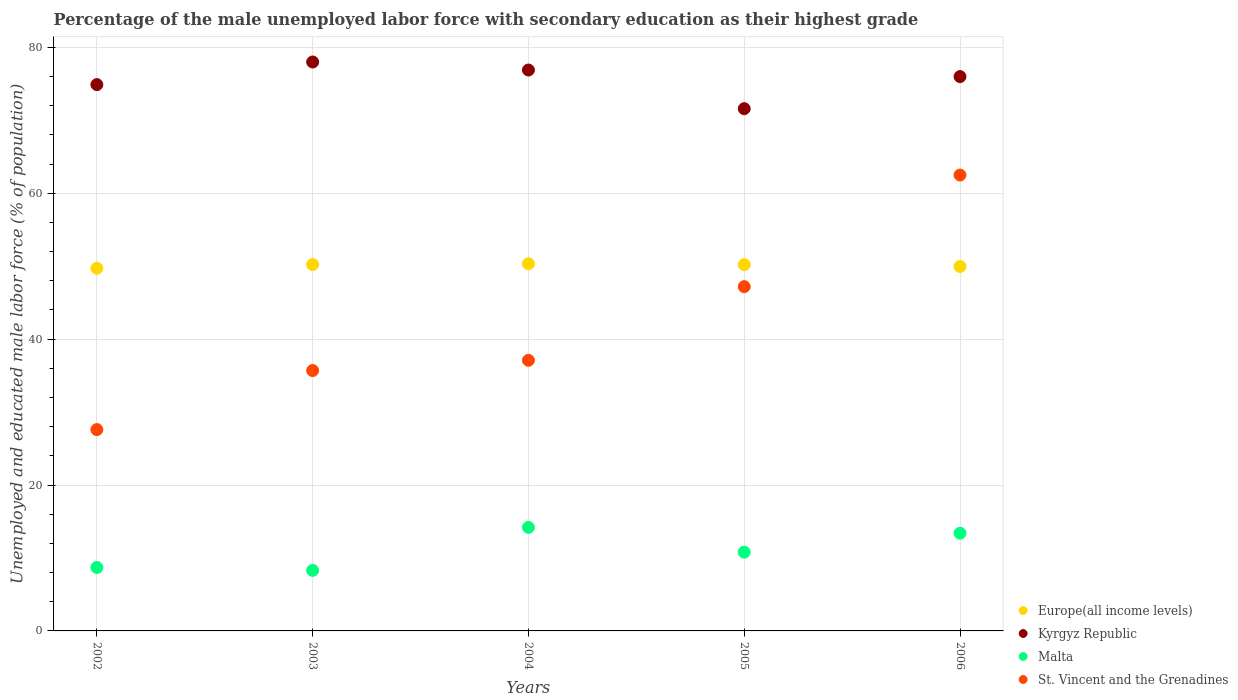What is the percentage of the unemployed male labor force with secondary education in Malta in 2003?
Make the answer very short. 8.3. Across all years, what is the minimum percentage of the unemployed male labor force with secondary education in Kyrgyz Republic?
Give a very brief answer. 71.6. In which year was the percentage of the unemployed male labor force with secondary education in St. Vincent and the Grenadines maximum?
Your response must be concise. 2006. What is the total percentage of the unemployed male labor force with secondary education in Malta in the graph?
Offer a very short reply. 55.4. What is the difference between the percentage of the unemployed male labor force with secondary education in Europe(all income levels) in 2002 and that in 2004?
Offer a terse response. -0.61. What is the difference between the percentage of the unemployed male labor force with secondary education in Malta in 2002 and the percentage of the unemployed male labor force with secondary education in St. Vincent and the Grenadines in 2005?
Offer a terse response. -38.5. What is the average percentage of the unemployed male labor force with secondary education in Malta per year?
Make the answer very short. 11.08. In the year 2004, what is the difference between the percentage of the unemployed male labor force with secondary education in Kyrgyz Republic and percentage of the unemployed male labor force with secondary education in Europe(all income levels)?
Provide a succinct answer. 26.56. In how many years, is the percentage of the unemployed male labor force with secondary education in Europe(all income levels) greater than 20 %?
Your answer should be very brief. 5. What is the ratio of the percentage of the unemployed male labor force with secondary education in Europe(all income levels) in 2003 to that in 2004?
Your answer should be compact. 1. What is the difference between the highest and the second highest percentage of the unemployed male labor force with secondary education in Malta?
Your response must be concise. 0.8. What is the difference between the highest and the lowest percentage of the unemployed male labor force with secondary education in Kyrgyz Republic?
Give a very brief answer. 6.4. Is the sum of the percentage of the unemployed male labor force with secondary education in Kyrgyz Republic in 2004 and 2006 greater than the maximum percentage of the unemployed male labor force with secondary education in Malta across all years?
Offer a terse response. Yes. Is it the case that in every year, the sum of the percentage of the unemployed male labor force with secondary education in Europe(all income levels) and percentage of the unemployed male labor force with secondary education in Malta  is greater than the percentage of the unemployed male labor force with secondary education in St. Vincent and the Grenadines?
Your response must be concise. Yes. Is the percentage of the unemployed male labor force with secondary education in Malta strictly greater than the percentage of the unemployed male labor force with secondary education in St. Vincent and the Grenadines over the years?
Provide a short and direct response. No. How many dotlines are there?
Provide a succinct answer. 4. How many years are there in the graph?
Provide a short and direct response. 5. What is the difference between two consecutive major ticks on the Y-axis?
Keep it short and to the point. 20. Does the graph contain any zero values?
Your answer should be compact. No. Where does the legend appear in the graph?
Provide a short and direct response. Bottom right. What is the title of the graph?
Your answer should be compact. Percentage of the male unemployed labor force with secondary education as their highest grade. Does "Liechtenstein" appear as one of the legend labels in the graph?
Your answer should be compact. No. What is the label or title of the X-axis?
Give a very brief answer. Years. What is the label or title of the Y-axis?
Offer a very short reply. Unemployed and educated male labor force (% of population). What is the Unemployed and educated male labor force (% of population) in Europe(all income levels) in 2002?
Ensure brevity in your answer.  49.72. What is the Unemployed and educated male labor force (% of population) in Kyrgyz Republic in 2002?
Give a very brief answer. 74.9. What is the Unemployed and educated male labor force (% of population) in Malta in 2002?
Give a very brief answer. 8.7. What is the Unemployed and educated male labor force (% of population) in St. Vincent and the Grenadines in 2002?
Give a very brief answer. 27.6. What is the Unemployed and educated male labor force (% of population) in Europe(all income levels) in 2003?
Offer a very short reply. 50.23. What is the Unemployed and educated male labor force (% of population) of Kyrgyz Republic in 2003?
Your answer should be very brief. 78. What is the Unemployed and educated male labor force (% of population) of Malta in 2003?
Provide a succinct answer. 8.3. What is the Unemployed and educated male labor force (% of population) of St. Vincent and the Grenadines in 2003?
Your answer should be compact. 35.7. What is the Unemployed and educated male labor force (% of population) in Europe(all income levels) in 2004?
Provide a succinct answer. 50.34. What is the Unemployed and educated male labor force (% of population) of Kyrgyz Republic in 2004?
Provide a succinct answer. 76.9. What is the Unemployed and educated male labor force (% of population) in Malta in 2004?
Offer a very short reply. 14.2. What is the Unemployed and educated male labor force (% of population) in St. Vincent and the Grenadines in 2004?
Make the answer very short. 37.1. What is the Unemployed and educated male labor force (% of population) in Europe(all income levels) in 2005?
Give a very brief answer. 50.22. What is the Unemployed and educated male labor force (% of population) of Kyrgyz Republic in 2005?
Make the answer very short. 71.6. What is the Unemployed and educated male labor force (% of population) in Malta in 2005?
Your answer should be compact. 10.8. What is the Unemployed and educated male labor force (% of population) of St. Vincent and the Grenadines in 2005?
Your response must be concise. 47.2. What is the Unemployed and educated male labor force (% of population) of Europe(all income levels) in 2006?
Your response must be concise. 49.97. What is the Unemployed and educated male labor force (% of population) of Malta in 2006?
Your answer should be very brief. 13.4. What is the Unemployed and educated male labor force (% of population) of St. Vincent and the Grenadines in 2006?
Your response must be concise. 62.5. Across all years, what is the maximum Unemployed and educated male labor force (% of population) in Europe(all income levels)?
Your answer should be compact. 50.34. Across all years, what is the maximum Unemployed and educated male labor force (% of population) in Malta?
Give a very brief answer. 14.2. Across all years, what is the maximum Unemployed and educated male labor force (% of population) of St. Vincent and the Grenadines?
Your response must be concise. 62.5. Across all years, what is the minimum Unemployed and educated male labor force (% of population) in Europe(all income levels)?
Make the answer very short. 49.72. Across all years, what is the minimum Unemployed and educated male labor force (% of population) in Kyrgyz Republic?
Your response must be concise. 71.6. Across all years, what is the minimum Unemployed and educated male labor force (% of population) of Malta?
Offer a very short reply. 8.3. Across all years, what is the minimum Unemployed and educated male labor force (% of population) in St. Vincent and the Grenadines?
Keep it short and to the point. 27.6. What is the total Unemployed and educated male labor force (% of population) of Europe(all income levels) in the graph?
Your response must be concise. 250.47. What is the total Unemployed and educated male labor force (% of population) in Kyrgyz Republic in the graph?
Offer a terse response. 377.4. What is the total Unemployed and educated male labor force (% of population) of Malta in the graph?
Offer a terse response. 55.4. What is the total Unemployed and educated male labor force (% of population) of St. Vincent and the Grenadines in the graph?
Offer a terse response. 210.1. What is the difference between the Unemployed and educated male labor force (% of population) of Europe(all income levels) in 2002 and that in 2003?
Give a very brief answer. -0.51. What is the difference between the Unemployed and educated male labor force (% of population) of Malta in 2002 and that in 2003?
Give a very brief answer. 0.4. What is the difference between the Unemployed and educated male labor force (% of population) in Europe(all income levels) in 2002 and that in 2004?
Your response must be concise. -0.61. What is the difference between the Unemployed and educated male labor force (% of population) of Malta in 2002 and that in 2004?
Make the answer very short. -5.5. What is the difference between the Unemployed and educated male labor force (% of population) of St. Vincent and the Grenadines in 2002 and that in 2004?
Provide a short and direct response. -9.5. What is the difference between the Unemployed and educated male labor force (% of population) of Europe(all income levels) in 2002 and that in 2005?
Make the answer very short. -0.49. What is the difference between the Unemployed and educated male labor force (% of population) in St. Vincent and the Grenadines in 2002 and that in 2005?
Provide a succinct answer. -19.6. What is the difference between the Unemployed and educated male labor force (% of population) in Europe(all income levels) in 2002 and that in 2006?
Provide a short and direct response. -0.24. What is the difference between the Unemployed and educated male labor force (% of population) in Malta in 2002 and that in 2006?
Offer a terse response. -4.7. What is the difference between the Unemployed and educated male labor force (% of population) of St. Vincent and the Grenadines in 2002 and that in 2006?
Make the answer very short. -34.9. What is the difference between the Unemployed and educated male labor force (% of population) of Europe(all income levels) in 2003 and that in 2004?
Give a very brief answer. -0.11. What is the difference between the Unemployed and educated male labor force (% of population) of St. Vincent and the Grenadines in 2003 and that in 2004?
Give a very brief answer. -1.4. What is the difference between the Unemployed and educated male labor force (% of population) in Europe(all income levels) in 2003 and that in 2005?
Give a very brief answer. 0.01. What is the difference between the Unemployed and educated male labor force (% of population) in Europe(all income levels) in 2003 and that in 2006?
Provide a short and direct response. 0.26. What is the difference between the Unemployed and educated male labor force (% of population) of Kyrgyz Republic in 2003 and that in 2006?
Your answer should be very brief. 2. What is the difference between the Unemployed and educated male labor force (% of population) in Malta in 2003 and that in 2006?
Provide a succinct answer. -5.1. What is the difference between the Unemployed and educated male labor force (% of population) in St. Vincent and the Grenadines in 2003 and that in 2006?
Your response must be concise. -26.8. What is the difference between the Unemployed and educated male labor force (% of population) in Europe(all income levels) in 2004 and that in 2005?
Your response must be concise. 0.12. What is the difference between the Unemployed and educated male labor force (% of population) in Kyrgyz Republic in 2004 and that in 2005?
Provide a short and direct response. 5.3. What is the difference between the Unemployed and educated male labor force (% of population) of St. Vincent and the Grenadines in 2004 and that in 2005?
Your response must be concise. -10.1. What is the difference between the Unemployed and educated male labor force (% of population) in Europe(all income levels) in 2004 and that in 2006?
Keep it short and to the point. 0.37. What is the difference between the Unemployed and educated male labor force (% of population) of Kyrgyz Republic in 2004 and that in 2006?
Your answer should be compact. 0.9. What is the difference between the Unemployed and educated male labor force (% of population) of St. Vincent and the Grenadines in 2004 and that in 2006?
Offer a very short reply. -25.4. What is the difference between the Unemployed and educated male labor force (% of population) of Europe(all income levels) in 2005 and that in 2006?
Offer a terse response. 0.25. What is the difference between the Unemployed and educated male labor force (% of population) in St. Vincent and the Grenadines in 2005 and that in 2006?
Provide a short and direct response. -15.3. What is the difference between the Unemployed and educated male labor force (% of population) in Europe(all income levels) in 2002 and the Unemployed and educated male labor force (% of population) in Kyrgyz Republic in 2003?
Your answer should be compact. -28.28. What is the difference between the Unemployed and educated male labor force (% of population) of Europe(all income levels) in 2002 and the Unemployed and educated male labor force (% of population) of Malta in 2003?
Give a very brief answer. 41.42. What is the difference between the Unemployed and educated male labor force (% of population) of Europe(all income levels) in 2002 and the Unemployed and educated male labor force (% of population) of St. Vincent and the Grenadines in 2003?
Your answer should be very brief. 14.02. What is the difference between the Unemployed and educated male labor force (% of population) in Kyrgyz Republic in 2002 and the Unemployed and educated male labor force (% of population) in Malta in 2003?
Offer a terse response. 66.6. What is the difference between the Unemployed and educated male labor force (% of population) in Kyrgyz Republic in 2002 and the Unemployed and educated male labor force (% of population) in St. Vincent and the Grenadines in 2003?
Provide a short and direct response. 39.2. What is the difference between the Unemployed and educated male labor force (% of population) of Malta in 2002 and the Unemployed and educated male labor force (% of population) of St. Vincent and the Grenadines in 2003?
Your response must be concise. -27. What is the difference between the Unemployed and educated male labor force (% of population) of Europe(all income levels) in 2002 and the Unemployed and educated male labor force (% of population) of Kyrgyz Republic in 2004?
Provide a succinct answer. -27.18. What is the difference between the Unemployed and educated male labor force (% of population) of Europe(all income levels) in 2002 and the Unemployed and educated male labor force (% of population) of Malta in 2004?
Make the answer very short. 35.52. What is the difference between the Unemployed and educated male labor force (% of population) of Europe(all income levels) in 2002 and the Unemployed and educated male labor force (% of population) of St. Vincent and the Grenadines in 2004?
Your answer should be compact. 12.62. What is the difference between the Unemployed and educated male labor force (% of population) of Kyrgyz Republic in 2002 and the Unemployed and educated male labor force (% of population) of Malta in 2004?
Provide a succinct answer. 60.7. What is the difference between the Unemployed and educated male labor force (% of population) in Kyrgyz Republic in 2002 and the Unemployed and educated male labor force (% of population) in St. Vincent and the Grenadines in 2004?
Keep it short and to the point. 37.8. What is the difference between the Unemployed and educated male labor force (% of population) of Malta in 2002 and the Unemployed and educated male labor force (% of population) of St. Vincent and the Grenadines in 2004?
Your answer should be very brief. -28.4. What is the difference between the Unemployed and educated male labor force (% of population) of Europe(all income levels) in 2002 and the Unemployed and educated male labor force (% of population) of Kyrgyz Republic in 2005?
Keep it short and to the point. -21.88. What is the difference between the Unemployed and educated male labor force (% of population) in Europe(all income levels) in 2002 and the Unemployed and educated male labor force (% of population) in Malta in 2005?
Provide a succinct answer. 38.92. What is the difference between the Unemployed and educated male labor force (% of population) of Europe(all income levels) in 2002 and the Unemployed and educated male labor force (% of population) of St. Vincent and the Grenadines in 2005?
Your answer should be very brief. 2.52. What is the difference between the Unemployed and educated male labor force (% of population) of Kyrgyz Republic in 2002 and the Unemployed and educated male labor force (% of population) of Malta in 2005?
Offer a terse response. 64.1. What is the difference between the Unemployed and educated male labor force (% of population) of Kyrgyz Republic in 2002 and the Unemployed and educated male labor force (% of population) of St. Vincent and the Grenadines in 2005?
Ensure brevity in your answer.  27.7. What is the difference between the Unemployed and educated male labor force (% of population) in Malta in 2002 and the Unemployed and educated male labor force (% of population) in St. Vincent and the Grenadines in 2005?
Offer a terse response. -38.5. What is the difference between the Unemployed and educated male labor force (% of population) of Europe(all income levels) in 2002 and the Unemployed and educated male labor force (% of population) of Kyrgyz Republic in 2006?
Your answer should be compact. -26.28. What is the difference between the Unemployed and educated male labor force (% of population) in Europe(all income levels) in 2002 and the Unemployed and educated male labor force (% of population) in Malta in 2006?
Your answer should be very brief. 36.32. What is the difference between the Unemployed and educated male labor force (% of population) in Europe(all income levels) in 2002 and the Unemployed and educated male labor force (% of population) in St. Vincent and the Grenadines in 2006?
Ensure brevity in your answer.  -12.78. What is the difference between the Unemployed and educated male labor force (% of population) of Kyrgyz Republic in 2002 and the Unemployed and educated male labor force (% of population) of Malta in 2006?
Ensure brevity in your answer.  61.5. What is the difference between the Unemployed and educated male labor force (% of population) of Kyrgyz Republic in 2002 and the Unemployed and educated male labor force (% of population) of St. Vincent and the Grenadines in 2006?
Your answer should be very brief. 12.4. What is the difference between the Unemployed and educated male labor force (% of population) in Malta in 2002 and the Unemployed and educated male labor force (% of population) in St. Vincent and the Grenadines in 2006?
Keep it short and to the point. -53.8. What is the difference between the Unemployed and educated male labor force (% of population) of Europe(all income levels) in 2003 and the Unemployed and educated male labor force (% of population) of Kyrgyz Republic in 2004?
Your response must be concise. -26.67. What is the difference between the Unemployed and educated male labor force (% of population) in Europe(all income levels) in 2003 and the Unemployed and educated male labor force (% of population) in Malta in 2004?
Your answer should be compact. 36.03. What is the difference between the Unemployed and educated male labor force (% of population) in Europe(all income levels) in 2003 and the Unemployed and educated male labor force (% of population) in St. Vincent and the Grenadines in 2004?
Keep it short and to the point. 13.13. What is the difference between the Unemployed and educated male labor force (% of population) of Kyrgyz Republic in 2003 and the Unemployed and educated male labor force (% of population) of Malta in 2004?
Offer a terse response. 63.8. What is the difference between the Unemployed and educated male labor force (% of population) of Kyrgyz Republic in 2003 and the Unemployed and educated male labor force (% of population) of St. Vincent and the Grenadines in 2004?
Your response must be concise. 40.9. What is the difference between the Unemployed and educated male labor force (% of population) of Malta in 2003 and the Unemployed and educated male labor force (% of population) of St. Vincent and the Grenadines in 2004?
Your answer should be compact. -28.8. What is the difference between the Unemployed and educated male labor force (% of population) of Europe(all income levels) in 2003 and the Unemployed and educated male labor force (% of population) of Kyrgyz Republic in 2005?
Offer a terse response. -21.37. What is the difference between the Unemployed and educated male labor force (% of population) in Europe(all income levels) in 2003 and the Unemployed and educated male labor force (% of population) in Malta in 2005?
Your answer should be very brief. 39.43. What is the difference between the Unemployed and educated male labor force (% of population) in Europe(all income levels) in 2003 and the Unemployed and educated male labor force (% of population) in St. Vincent and the Grenadines in 2005?
Provide a succinct answer. 3.03. What is the difference between the Unemployed and educated male labor force (% of population) in Kyrgyz Republic in 2003 and the Unemployed and educated male labor force (% of population) in Malta in 2005?
Give a very brief answer. 67.2. What is the difference between the Unemployed and educated male labor force (% of population) in Kyrgyz Republic in 2003 and the Unemployed and educated male labor force (% of population) in St. Vincent and the Grenadines in 2005?
Ensure brevity in your answer.  30.8. What is the difference between the Unemployed and educated male labor force (% of population) in Malta in 2003 and the Unemployed and educated male labor force (% of population) in St. Vincent and the Grenadines in 2005?
Provide a short and direct response. -38.9. What is the difference between the Unemployed and educated male labor force (% of population) of Europe(all income levels) in 2003 and the Unemployed and educated male labor force (% of population) of Kyrgyz Republic in 2006?
Your answer should be very brief. -25.77. What is the difference between the Unemployed and educated male labor force (% of population) in Europe(all income levels) in 2003 and the Unemployed and educated male labor force (% of population) in Malta in 2006?
Your response must be concise. 36.83. What is the difference between the Unemployed and educated male labor force (% of population) of Europe(all income levels) in 2003 and the Unemployed and educated male labor force (% of population) of St. Vincent and the Grenadines in 2006?
Keep it short and to the point. -12.27. What is the difference between the Unemployed and educated male labor force (% of population) in Kyrgyz Republic in 2003 and the Unemployed and educated male labor force (% of population) in Malta in 2006?
Offer a terse response. 64.6. What is the difference between the Unemployed and educated male labor force (% of population) of Malta in 2003 and the Unemployed and educated male labor force (% of population) of St. Vincent and the Grenadines in 2006?
Your answer should be very brief. -54.2. What is the difference between the Unemployed and educated male labor force (% of population) in Europe(all income levels) in 2004 and the Unemployed and educated male labor force (% of population) in Kyrgyz Republic in 2005?
Make the answer very short. -21.26. What is the difference between the Unemployed and educated male labor force (% of population) of Europe(all income levels) in 2004 and the Unemployed and educated male labor force (% of population) of Malta in 2005?
Provide a short and direct response. 39.54. What is the difference between the Unemployed and educated male labor force (% of population) in Europe(all income levels) in 2004 and the Unemployed and educated male labor force (% of population) in St. Vincent and the Grenadines in 2005?
Give a very brief answer. 3.14. What is the difference between the Unemployed and educated male labor force (% of population) in Kyrgyz Republic in 2004 and the Unemployed and educated male labor force (% of population) in Malta in 2005?
Offer a terse response. 66.1. What is the difference between the Unemployed and educated male labor force (% of population) in Kyrgyz Republic in 2004 and the Unemployed and educated male labor force (% of population) in St. Vincent and the Grenadines in 2005?
Give a very brief answer. 29.7. What is the difference between the Unemployed and educated male labor force (% of population) of Malta in 2004 and the Unemployed and educated male labor force (% of population) of St. Vincent and the Grenadines in 2005?
Ensure brevity in your answer.  -33. What is the difference between the Unemployed and educated male labor force (% of population) in Europe(all income levels) in 2004 and the Unemployed and educated male labor force (% of population) in Kyrgyz Republic in 2006?
Keep it short and to the point. -25.66. What is the difference between the Unemployed and educated male labor force (% of population) of Europe(all income levels) in 2004 and the Unemployed and educated male labor force (% of population) of Malta in 2006?
Your answer should be compact. 36.94. What is the difference between the Unemployed and educated male labor force (% of population) of Europe(all income levels) in 2004 and the Unemployed and educated male labor force (% of population) of St. Vincent and the Grenadines in 2006?
Your answer should be very brief. -12.16. What is the difference between the Unemployed and educated male labor force (% of population) of Kyrgyz Republic in 2004 and the Unemployed and educated male labor force (% of population) of Malta in 2006?
Your answer should be compact. 63.5. What is the difference between the Unemployed and educated male labor force (% of population) of Kyrgyz Republic in 2004 and the Unemployed and educated male labor force (% of population) of St. Vincent and the Grenadines in 2006?
Offer a terse response. 14.4. What is the difference between the Unemployed and educated male labor force (% of population) in Malta in 2004 and the Unemployed and educated male labor force (% of population) in St. Vincent and the Grenadines in 2006?
Your answer should be very brief. -48.3. What is the difference between the Unemployed and educated male labor force (% of population) in Europe(all income levels) in 2005 and the Unemployed and educated male labor force (% of population) in Kyrgyz Republic in 2006?
Your answer should be very brief. -25.78. What is the difference between the Unemployed and educated male labor force (% of population) of Europe(all income levels) in 2005 and the Unemployed and educated male labor force (% of population) of Malta in 2006?
Keep it short and to the point. 36.82. What is the difference between the Unemployed and educated male labor force (% of population) in Europe(all income levels) in 2005 and the Unemployed and educated male labor force (% of population) in St. Vincent and the Grenadines in 2006?
Provide a short and direct response. -12.28. What is the difference between the Unemployed and educated male labor force (% of population) in Kyrgyz Republic in 2005 and the Unemployed and educated male labor force (% of population) in Malta in 2006?
Provide a succinct answer. 58.2. What is the difference between the Unemployed and educated male labor force (% of population) in Malta in 2005 and the Unemployed and educated male labor force (% of population) in St. Vincent and the Grenadines in 2006?
Your answer should be very brief. -51.7. What is the average Unemployed and educated male labor force (% of population) in Europe(all income levels) per year?
Your answer should be very brief. 50.09. What is the average Unemployed and educated male labor force (% of population) of Kyrgyz Republic per year?
Offer a very short reply. 75.48. What is the average Unemployed and educated male labor force (% of population) of Malta per year?
Give a very brief answer. 11.08. What is the average Unemployed and educated male labor force (% of population) of St. Vincent and the Grenadines per year?
Your answer should be compact. 42.02. In the year 2002, what is the difference between the Unemployed and educated male labor force (% of population) in Europe(all income levels) and Unemployed and educated male labor force (% of population) in Kyrgyz Republic?
Your answer should be compact. -25.18. In the year 2002, what is the difference between the Unemployed and educated male labor force (% of population) in Europe(all income levels) and Unemployed and educated male labor force (% of population) in Malta?
Provide a short and direct response. 41.02. In the year 2002, what is the difference between the Unemployed and educated male labor force (% of population) in Europe(all income levels) and Unemployed and educated male labor force (% of population) in St. Vincent and the Grenadines?
Make the answer very short. 22.12. In the year 2002, what is the difference between the Unemployed and educated male labor force (% of population) of Kyrgyz Republic and Unemployed and educated male labor force (% of population) of Malta?
Keep it short and to the point. 66.2. In the year 2002, what is the difference between the Unemployed and educated male labor force (% of population) of Kyrgyz Republic and Unemployed and educated male labor force (% of population) of St. Vincent and the Grenadines?
Your answer should be very brief. 47.3. In the year 2002, what is the difference between the Unemployed and educated male labor force (% of population) of Malta and Unemployed and educated male labor force (% of population) of St. Vincent and the Grenadines?
Make the answer very short. -18.9. In the year 2003, what is the difference between the Unemployed and educated male labor force (% of population) in Europe(all income levels) and Unemployed and educated male labor force (% of population) in Kyrgyz Republic?
Offer a terse response. -27.77. In the year 2003, what is the difference between the Unemployed and educated male labor force (% of population) of Europe(all income levels) and Unemployed and educated male labor force (% of population) of Malta?
Ensure brevity in your answer.  41.93. In the year 2003, what is the difference between the Unemployed and educated male labor force (% of population) in Europe(all income levels) and Unemployed and educated male labor force (% of population) in St. Vincent and the Grenadines?
Provide a succinct answer. 14.53. In the year 2003, what is the difference between the Unemployed and educated male labor force (% of population) in Kyrgyz Republic and Unemployed and educated male labor force (% of population) in Malta?
Keep it short and to the point. 69.7. In the year 2003, what is the difference between the Unemployed and educated male labor force (% of population) in Kyrgyz Republic and Unemployed and educated male labor force (% of population) in St. Vincent and the Grenadines?
Your answer should be compact. 42.3. In the year 2003, what is the difference between the Unemployed and educated male labor force (% of population) of Malta and Unemployed and educated male labor force (% of population) of St. Vincent and the Grenadines?
Your response must be concise. -27.4. In the year 2004, what is the difference between the Unemployed and educated male labor force (% of population) in Europe(all income levels) and Unemployed and educated male labor force (% of population) in Kyrgyz Republic?
Your answer should be compact. -26.56. In the year 2004, what is the difference between the Unemployed and educated male labor force (% of population) in Europe(all income levels) and Unemployed and educated male labor force (% of population) in Malta?
Offer a terse response. 36.14. In the year 2004, what is the difference between the Unemployed and educated male labor force (% of population) of Europe(all income levels) and Unemployed and educated male labor force (% of population) of St. Vincent and the Grenadines?
Your answer should be compact. 13.24. In the year 2004, what is the difference between the Unemployed and educated male labor force (% of population) in Kyrgyz Republic and Unemployed and educated male labor force (% of population) in Malta?
Offer a terse response. 62.7. In the year 2004, what is the difference between the Unemployed and educated male labor force (% of population) of Kyrgyz Republic and Unemployed and educated male labor force (% of population) of St. Vincent and the Grenadines?
Offer a terse response. 39.8. In the year 2004, what is the difference between the Unemployed and educated male labor force (% of population) in Malta and Unemployed and educated male labor force (% of population) in St. Vincent and the Grenadines?
Your answer should be very brief. -22.9. In the year 2005, what is the difference between the Unemployed and educated male labor force (% of population) in Europe(all income levels) and Unemployed and educated male labor force (% of population) in Kyrgyz Republic?
Ensure brevity in your answer.  -21.38. In the year 2005, what is the difference between the Unemployed and educated male labor force (% of population) in Europe(all income levels) and Unemployed and educated male labor force (% of population) in Malta?
Make the answer very short. 39.42. In the year 2005, what is the difference between the Unemployed and educated male labor force (% of population) in Europe(all income levels) and Unemployed and educated male labor force (% of population) in St. Vincent and the Grenadines?
Offer a terse response. 3.02. In the year 2005, what is the difference between the Unemployed and educated male labor force (% of population) of Kyrgyz Republic and Unemployed and educated male labor force (% of population) of Malta?
Keep it short and to the point. 60.8. In the year 2005, what is the difference between the Unemployed and educated male labor force (% of population) in Kyrgyz Republic and Unemployed and educated male labor force (% of population) in St. Vincent and the Grenadines?
Your response must be concise. 24.4. In the year 2005, what is the difference between the Unemployed and educated male labor force (% of population) in Malta and Unemployed and educated male labor force (% of population) in St. Vincent and the Grenadines?
Your response must be concise. -36.4. In the year 2006, what is the difference between the Unemployed and educated male labor force (% of population) in Europe(all income levels) and Unemployed and educated male labor force (% of population) in Kyrgyz Republic?
Ensure brevity in your answer.  -26.03. In the year 2006, what is the difference between the Unemployed and educated male labor force (% of population) of Europe(all income levels) and Unemployed and educated male labor force (% of population) of Malta?
Provide a short and direct response. 36.57. In the year 2006, what is the difference between the Unemployed and educated male labor force (% of population) of Europe(all income levels) and Unemployed and educated male labor force (% of population) of St. Vincent and the Grenadines?
Keep it short and to the point. -12.53. In the year 2006, what is the difference between the Unemployed and educated male labor force (% of population) in Kyrgyz Republic and Unemployed and educated male labor force (% of population) in Malta?
Offer a very short reply. 62.6. In the year 2006, what is the difference between the Unemployed and educated male labor force (% of population) of Kyrgyz Republic and Unemployed and educated male labor force (% of population) of St. Vincent and the Grenadines?
Your response must be concise. 13.5. In the year 2006, what is the difference between the Unemployed and educated male labor force (% of population) in Malta and Unemployed and educated male labor force (% of population) in St. Vincent and the Grenadines?
Your answer should be very brief. -49.1. What is the ratio of the Unemployed and educated male labor force (% of population) in Europe(all income levels) in 2002 to that in 2003?
Offer a very short reply. 0.99. What is the ratio of the Unemployed and educated male labor force (% of population) of Kyrgyz Republic in 2002 to that in 2003?
Ensure brevity in your answer.  0.96. What is the ratio of the Unemployed and educated male labor force (% of population) in Malta in 2002 to that in 2003?
Ensure brevity in your answer.  1.05. What is the ratio of the Unemployed and educated male labor force (% of population) of St. Vincent and the Grenadines in 2002 to that in 2003?
Keep it short and to the point. 0.77. What is the ratio of the Unemployed and educated male labor force (% of population) of Malta in 2002 to that in 2004?
Provide a short and direct response. 0.61. What is the ratio of the Unemployed and educated male labor force (% of population) of St. Vincent and the Grenadines in 2002 to that in 2004?
Your answer should be very brief. 0.74. What is the ratio of the Unemployed and educated male labor force (% of population) in Europe(all income levels) in 2002 to that in 2005?
Keep it short and to the point. 0.99. What is the ratio of the Unemployed and educated male labor force (% of population) of Kyrgyz Republic in 2002 to that in 2005?
Keep it short and to the point. 1.05. What is the ratio of the Unemployed and educated male labor force (% of population) in Malta in 2002 to that in 2005?
Your answer should be compact. 0.81. What is the ratio of the Unemployed and educated male labor force (% of population) of St. Vincent and the Grenadines in 2002 to that in 2005?
Your answer should be very brief. 0.58. What is the ratio of the Unemployed and educated male labor force (% of population) of Kyrgyz Republic in 2002 to that in 2006?
Give a very brief answer. 0.99. What is the ratio of the Unemployed and educated male labor force (% of population) of Malta in 2002 to that in 2006?
Keep it short and to the point. 0.65. What is the ratio of the Unemployed and educated male labor force (% of population) of St. Vincent and the Grenadines in 2002 to that in 2006?
Your response must be concise. 0.44. What is the ratio of the Unemployed and educated male labor force (% of population) of Europe(all income levels) in 2003 to that in 2004?
Your answer should be very brief. 1. What is the ratio of the Unemployed and educated male labor force (% of population) of Kyrgyz Republic in 2003 to that in 2004?
Your response must be concise. 1.01. What is the ratio of the Unemployed and educated male labor force (% of population) in Malta in 2003 to that in 2004?
Give a very brief answer. 0.58. What is the ratio of the Unemployed and educated male labor force (% of population) in St. Vincent and the Grenadines in 2003 to that in 2004?
Your response must be concise. 0.96. What is the ratio of the Unemployed and educated male labor force (% of population) in Kyrgyz Republic in 2003 to that in 2005?
Provide a succinct answer. 1.09. What is the ratio of the Unemployed and educated male labor force (% of population) in Malta in 2003 to that in 2005?
Provide a succinct answer. 0.77. What is the ratio of the Unemployed and educated male labor force (% of population) of St. Vincent and the Grenadines in 2003 to that in 2005?
Your response must be concise. 0.76. What is the ratio of the Unemployed and educated male labor force (% of population) in Europe(all income levels) in 2003 to that in 2006?
Offer a terse response. 1.01. What is the ratio of the Unemployed and educated male labor force (% of population) of Kyrgyz Republic in 2003 to that in 2006?
Give a very brief answer. 1.03. What is the ratio of the Unemployed and educated male labor force (% of population) in Malta in 2003 to that in 2006?
Offer a terse response. 0.62. What is the ratio of the Unemployed and educated male labor force (% of population) of St. Vincent and the Grenadines in 2003 to that in 2006?
Offer a terse response. 0.57. What is the ratio of the Unemployed and educated male labor force (% of population) of Europe(all income levels) in 2004 to that in 2005?
Ensure brevity in your answer.  1. What is the ratio of the Unemployed and educated male labor force (% of population) of Kyrgyz Republic in 2004 to that in 2005?
Make the answer very short. 1.07. What is the ratio of the Unemployed and educated male labor force (% of population) in Malta in 2004 to that in 2005?
Make the answer very short. 1.31. What is the ratio of the Unemployed and educated male labor force (% of population) of St. Vincent and the Grenadines in 2004 to that in 2005?
Your answer should be compact. 0.79. What is the ratio of the Unemployed and educated male labor force (% of population) of Europe(all income levels) in 2004 to that in 2006?
Keep it short and to the point. 1.01. What is the ratio of the Unemployed and educated male labor force (% of population) of Kyrgyz Republic in 2004 to that in 2006?
Give a very brief answer. 1.01. What is the ratio of the Unemployed and educated male labor force (% of population) in Malta in 2004 to that in 2006?
Your answer should be compact. 1.06. What is the ratio of the Unemployed and educated male labor force (% of population) of St. Vincent and the Grenadines in 2004 to that in 2006?
Provide a short and direct response. 0.59. What is the ratio of the Unemployed and educated male labor force (% of population) in Europe(all income levels) in 2005 to that in 2006?
Give a very brief answer. 1. What is the ratio of the Unemployed and educated male labor force (% of population) of Kyrgyz Republic in 2005 to that in 2006?
Ensure brevity in your answer.  0.94. What is the ratio of the Unemployed and educated male labor force (% of population) of Malta in 2005 to that in 2006?
Offer a very short reply. 0.81. What is the ratio of the Unemployed and educated male labor force (% of population) in St. Vincent and the Grenadines in 2005 to that in 2006?
Ensure brevity in your answer.  0.76. What is the difference between the highest and the second highest Unemployed and educated male labor force (% of population) of Europe(all income levels)?
Give a very brief answer. 0.11. What is the difference between the highest and the second highest Unemployed and educated male labor force (% of population) in Malta?
Keep it short and to the point. 0.8. What is the difference between the highest and the second highest Unemployed and educated male labor force (% of population) of St. Vincent and the Grenadines?
Provide a succinct answer. 15.3. What is the difference between the highest and the lowest Unemployed and educated male labor force (% of population) in Europe(all income levels)?
Provide a short and direct response. 0.61. What is the difference between the highest and the lowest Unemployed and educated male labor force (% of population) of St. Vincent and the Grenadines?
Your answer should be compact. 34.9. 